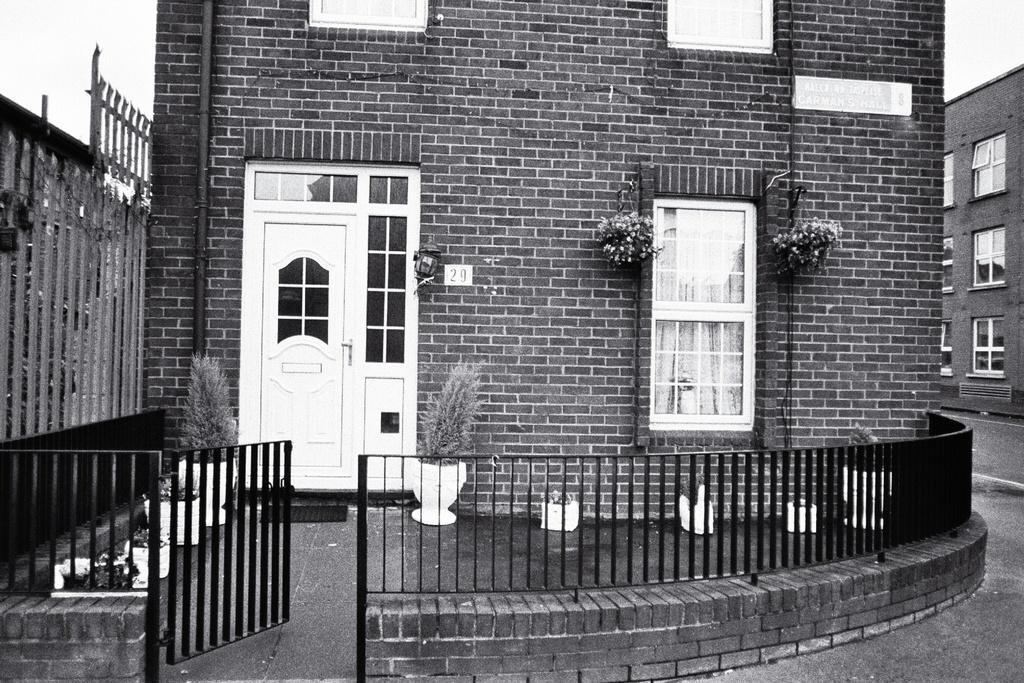Can you describe this image briefly? Here this is a black and white image, in which we can see buildings and houses present and we can also see windows and doors present and in the front we can see gate and railing present and we can also see plants present on the ground. 